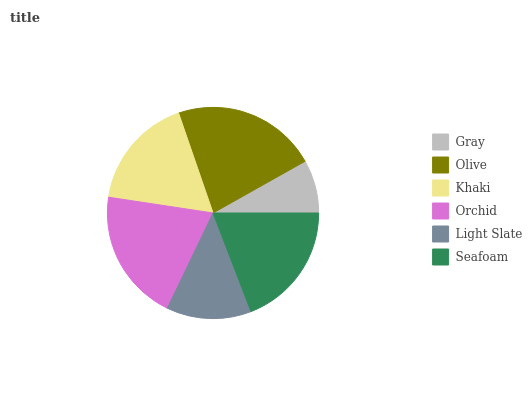Is Gray the minimum?
Answer yes or no. Yes. Is Olive the maximum?
Answer yes or no. Yes. Is Khaki the minimum?
Answer yes or no. No. Is Khaki the maximum?
Answer yes or no. No. Is Olive greater than Khaki?
Answer yes or no. Yes. Is Khaki less than Olive?
Answer yes or no. Yes. Is Khaki greater than Olive?
Answer yes or no. No. Is Olive less than Khaki?
Answer yes or no. No. Is Seafoam the high median?
Answer yes or no. Yes. Is Khaki the low median?
Answer yes or no. Yes. Is Gray the high median?
Answer yes or no. No. Is Gray the low median?
Answer yes or no. No. 